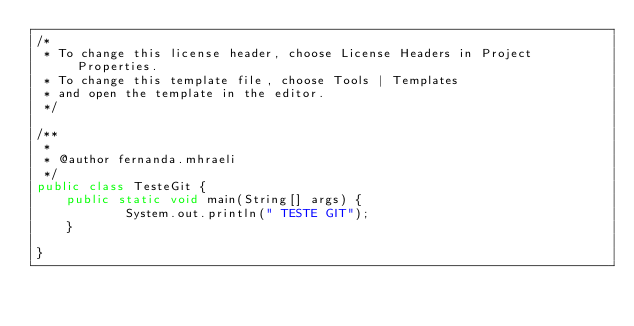<code> <loc_0><loc_0><loc_500><loc_500><_Java_>/*
 * To change this license header, choose License Headers in Project Properties.
 * To change this template file, choose Tools | Templates
 * and open the template in the editor.
 */

/**
 *
 * @author fernanda.mhraeli
 */
public class TesteGit {
    public static void main(String[] args) {
            System.out.println(" TESTE GIT");
    }
    
}
</code> 